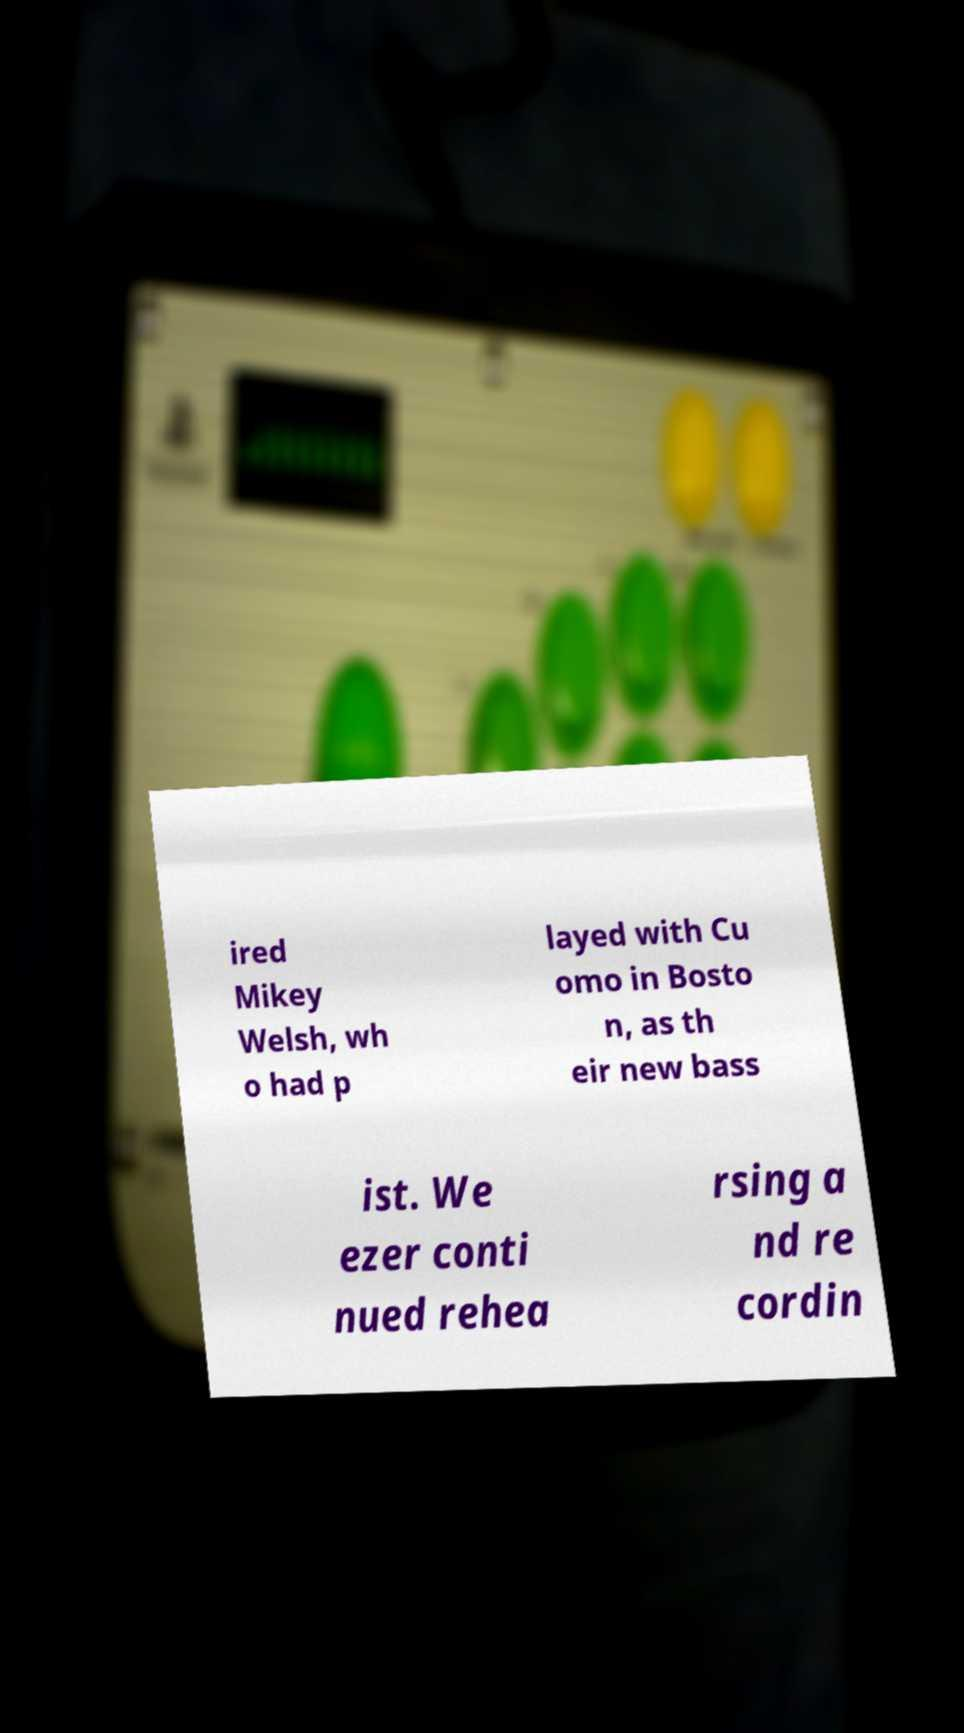Can you read and provide the text displayed in the image?This photo seems to have some interesting text. Can you extract and type it out for me? ired Mikey Welsh, wh o had p layed with Cu omo in Bosto n, as th eir new bass ist. We ezer conti nued rehea rsing a nd re cordin 